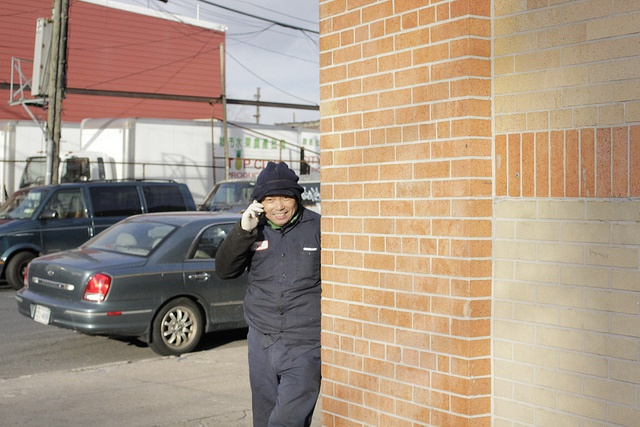Describe the objects in this image and their specific colors. I can see car in brown, gray, black, and darkgray tones, people in brown, gray, black, and ivory tones, truck in brown, black, gray, and darkblue tones, car in brown, black, gray, and darkblue tones, and car in brown, gray, and darkgray tones in this image. 